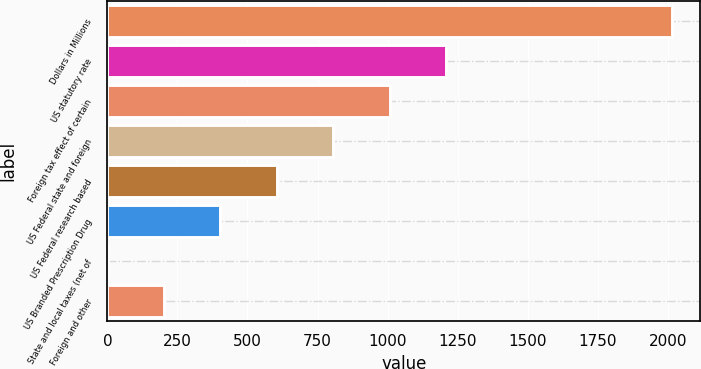Convert chart to OTSL. <chart><loc_0><loc_0><loc_500><loc_500><bar_chart><fcel>Dollars in Millions<fcel>US statutory rate<fcel>Foreign tax effect of certain<fcel>US Federal state and foreign<fcel>US Federal research based<fcel>US Branded Prescription Drug<fcel>State and local taxes (net of<fcel>Foreign and other<nl><fcel>2014<fcel>1208.72<fcel>1007.4<fcel>806.08<fcel>604.76<fcel>403.44<fcel>0.8<fcel>202.12<nl></chart> 